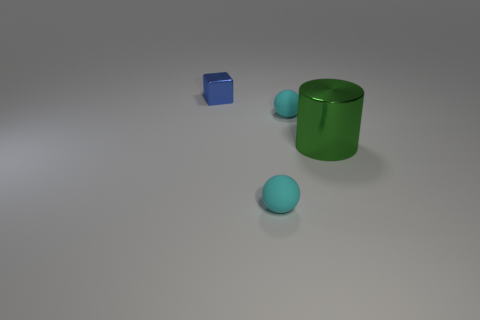There is a object that is on the left side of the tiny thing in front of the cylinder; what is its color?
Provide a succinct answer. Blue. Are there fewer metal objects than big green metal objects?
Your answer should be compact. No. Is there a gray cube that has the same material as the big cylinder?
Provide a short and direct response. No. There is a green shiny object; is it the same shape as the thing that is in front of the green cylinder?
Your response must be concise. No. Are there any tiny cyan rubber objects to the left of the tiny cube?
Provide a short and direct response. No. What number of small rubber things have the same shape as the large metal thing?
Offer a terse response. 0. Are the cylinder and the tiny cyan thing that is behind the green shiny cylinder made of the same material?
Provide a short and direct response. No. What number of small blue cylinders are there?
Ensure brevity in your answer.  0. There is a cyan sphere behind the big green metallic cylinder; what size is it?
Offer a terse response. Small. How many other blue things have the same size as the blue object?
Offer a terse response. 0. 